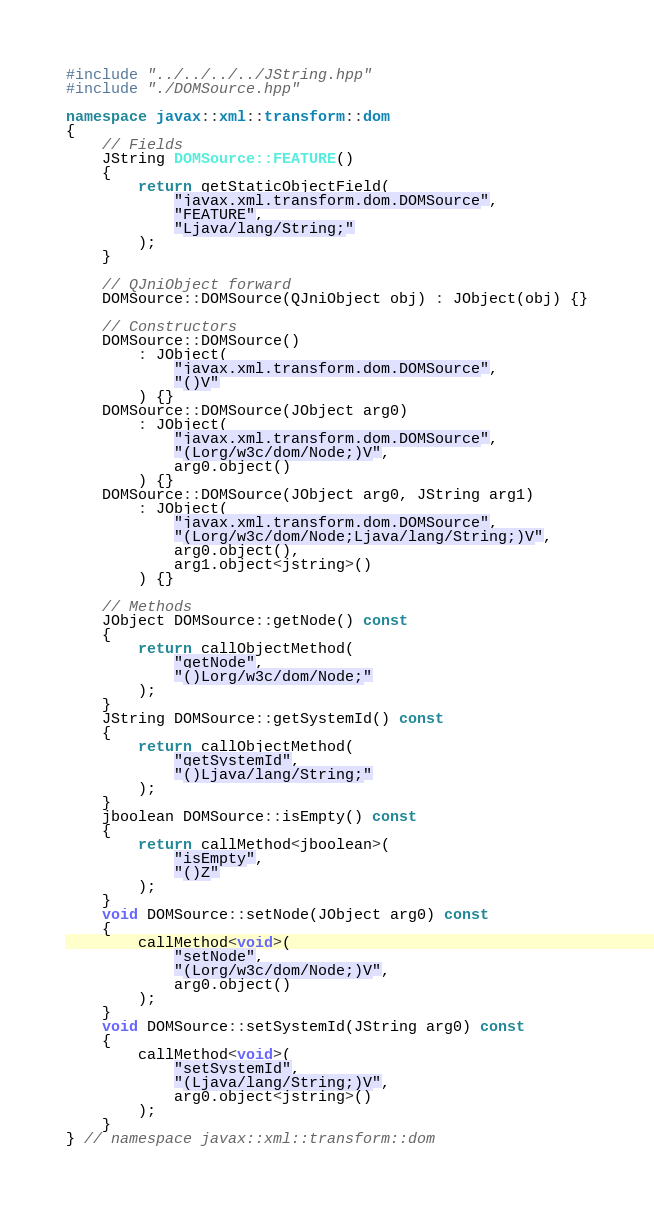Convert code to text. <code><loc_0><loc_0><loc_500><loc_500><_C++_>#include "../../../../JString.hpp"
#include "./DOMSource.hpp"

namespace javax::xml::transform::dom
{
	// Fields
	JString DOMSource::FEATURE()
	{
		return getStaticObjectField(
			"javax.xml.transform.dom.DOMSource",
			"FEATURE",
			"Ljava/lang/String;"
		);
	}
	
	// QJniObject forward
	DOMSource::DOMSource(QJniObject obj) : JObject(obj) {}
	
	// Constructors
	DOMSource::DOMSource()
		: JObject(
			"javax.xml.transform.dom.DOMSource",
			"()V"
		) {}
	DOMSource::DOMSource(JObject arg0)
		: JObject(
			"javax.xml.transform.dom.DOMSource",
			"(Lorg/w3c/dom/Node;)V",
			arg0.object()
		) {}
	DOMSource::DOMSource(JObject arg0, JString arg1)
		: JObject(
			"javax.xml.transform.dom.DOMSource",
			"(Lorg/w3c/dom/Node;Ljava/lang/String;)V",
			arg0.object(),
			arg1.object<jstring>()
		) {}
	
	// Methods
	JObject DOMSource::getNode() const
	{
		return callObjectMethod(
			"getNode",
			"()Lorg/w3c/dom/Node;"
		);
	}
	JString DOMSource::getSystemId() const
	{
		return callObjectMethod(
			"getSystemId",
			"()Ljava/lang/String;"
		);
	}
	jboolean DOMSource::isEmpty() const
	{
		return callMethod<jboolean>(
			"isEmpty",
			"()Z"
		);
	}
	void DOMSource::setNode(JObject arg0) const
	{
		callMethod<void>(
			"setNode",
			"(Lorg/w3c/dom/Node;)V",
			arg0.object()
		);
	}
	void DOMSource::setSystemId(JString arg0) const
	{
		callMethod<void>(
			"setSystemId",
			"(Ljava/lang/String;)V",
			arg0.object<jstring>()
		);
	}
} // namespace javax::xml::transform::dom

</code> 